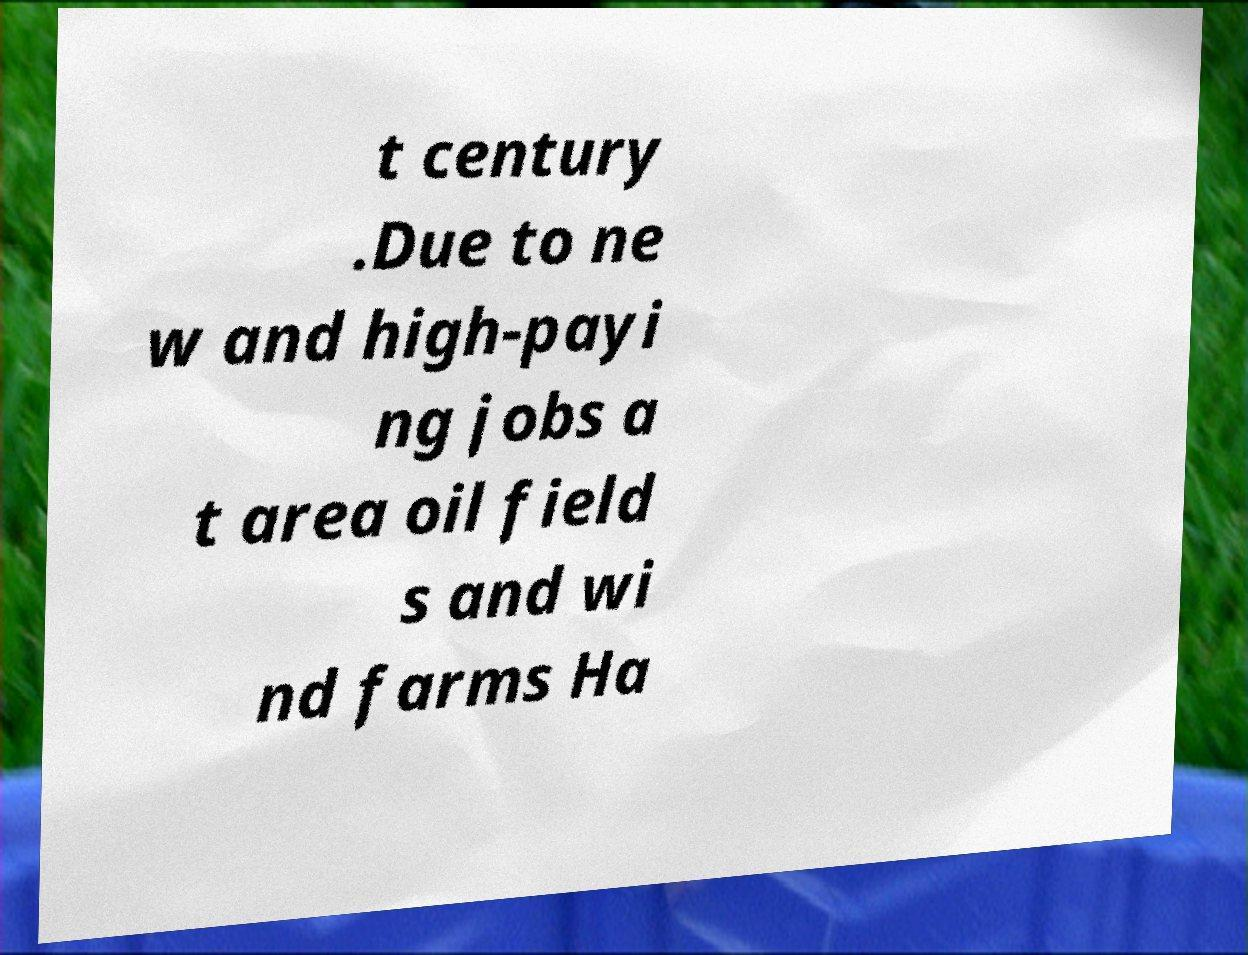For documentation purposes, I need the text within this image transcribed. Could you provide that? t century .Due to ne w and high-payi ng jobs a t area oil field s and wi nd farms Ha 